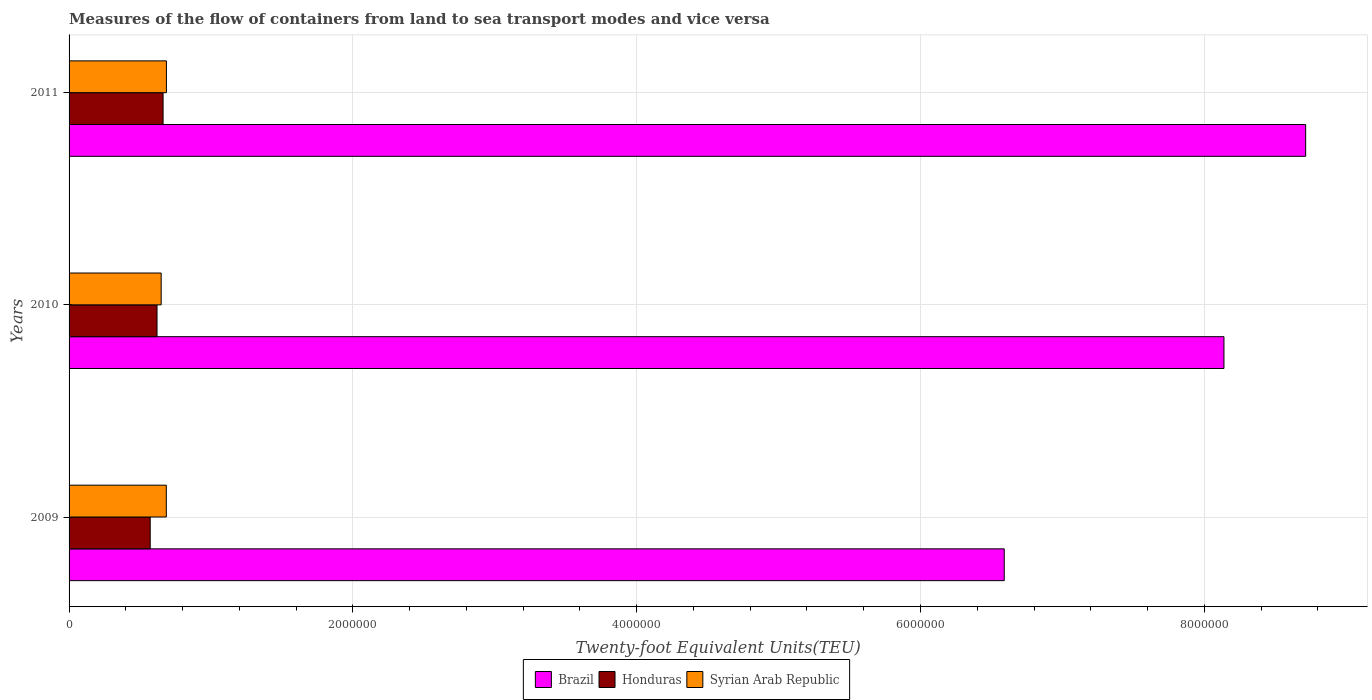Are the number of bars per tick equal to the number of legend labels?
Ensure brevity in your answer.  Yes. How many bars are there on the 1st tick from the top?
Provide a succinct answer. 3. How many bars are there on the 3rd tick from the bottom?
Keep it short and to the point. 3. What is the label of the 2nd group of bars from the top?
Offer a very short reply. 2010. In how many cases, is the number of bars for a given year not equal to the number of legend labels?
Provide a short and direct response. 0. What is the container port traffic in Brazil in 2009?
Provide a succinct answer. 6.59e+06. Across all years, what is the maximum container port traffic in Honduras?
Provide a short and direct response. 6.62e+05. Across all years, what is the minimum container port traffic in Brazil?
Your answer should be compact. 6.59e+06. In which year was the container port traffic in Brazil maximum?
Keep it short and to the point. 2011. In which year was the container port traffic in Syrian Arab Republic minimum?
Give a very brief answer. 2010. What is the total container port traffic in Brazil in the graph?
Your answer should be very brief. 2.34e+07. What is the difference between the container port traffic in Brazil in 2009 and that in 2010?
Give a very brief answer. -1.55e+06. What is the difference between the container port traffic in Honduras in 2010 and the container port traffic in Brazil in 2011?
Your answer should be compact. -8.09e+06. What is the average container port traffic in Brazil per year?
Provide a short and direct response. 7.81e+06. In the year 2010, what is the difference between the container port traffic in Brazil and container port traffic in Syrian Arab Republic?
Provide a short and direct response. 7.49e+06. What is the ratio of the container port traffic in Honduras in 2010 to that in 2011?
Give a very brief answer. 0.94. What is the difference between the highest and the second highest container port traffic in Syrian Arab Republic?
Offer a terse response. 699.29. What is the difference between the highest and the lowest container port traffic in Brazil?
Offer a terse response. 2.12e+06. In how many years, is the container port traffic in Honduras greater than the average container port traffic in Honduras taken over all years?
Your answer should be compact. 2. Is the sum of the container port traffic in Honduras in 2009 and 2011 greater than the maximum container port traffic in Brazil across all years?
Make the answer very short. No. What does the 2nd bar from the top in 2011 represents?
Provide a succinct answer. Honduras. What does the 3rd bar from the bottom in 2009 represents?
Ensure brevity in your answer.  Syrian Arab Republic. Is it the case that in every year, the sum of the container port traffic in Brazil and container port traffic in Syrian Arab Republic is greater than the container port traffic in Honduras?
Your response must be concise. Yes. Does the graph contain grids?
Keep it short and to the point. Yes. Where does the legend appear in the graph?
Provide a succinct answer. Bottom center. What is the title of the graph?
Keep it short and to the point. Measures of the flow of containers from land to sea transport modes and vice versa. What is the label or title of the X-axis?
Your answer should be compact. Twenty-foot Equivalent Units(TEU). What is the label or title of the Y-axis?
Your answer should be compact. Years. What is the Twenty-foot Equivalent Units(TEU) in Brazil in 2009?
Ensure brevity in your answer.  6.59e+06. What is the Twenty-foot Equivalent Units(TEU) in Honduras in 2009?
Your response must be concise. 5.72e+05. What is the Twenty-foot Equivalent Units(TEU) in Syrian Arab Republic in 2009?
Offer a very short reply. 6.85e+05. What is the Twenty-foot Equivalent Units(TEU) in Brazil in 2010?
Give a very brief answer. 8.14e+06. What is the Twenty-foot Equivalent Units(TEU) in Honduras in 2010?
Provide a succinct answer. 6.20e+05. What is the Twenty-foot Equivalent Units(TEU) in Syrian Arab Republic in 2010?
Your response must be concise. 6.49e+05. What is the Twenty-foot Equivalent Units(TEU) of Brazil in 2011?
Make the answer very short. 8.71e+06. What is the Twenty-foot Equivalent Units(TEU) in Honduras in 2011?
Your answer should be compact. 6.62e+05. What is the Twenty-foot Equivalent Units(TEU) in Syrian Arab Republic in 2011?
Offer a terse response. 6.86e+05. Across all years, what is the maximum Twenty-foot Equivalent Units(TEU) of Brazil?
Your answer should be very brief. 8.71e+06. Across all years, what is the maximum Twenty-foot Equivalent Units(TEU) of Honduras?
Your answer should be very brief. 6.62e+05. Across all years, what is the maximum Twenty-foot Equivalent Units(TEU) in Syrian Arab Republic?
Give a very brief answer. 6.86e+05. Across all years, what is the minimum Twenty-foot Equivalent Units(TEU) in Brazil?
Keep it short and to the point. 6.59e+06. Across all years, what is the minimum Twenty-foot Equivalent Units(TEU) of Honduras?
Offer a very short reply. 5.72e+05. Across all years, what is the minimum Twenty-foot Equivalent Units(TEU) in Syrian Arab Republic?
Your answer should be compact. 6.49e+05. What is the total Twenty-foot Equivalent Units(TEU) of Brazil in the graph?
Provide a succinct answer. 2.34e+07. What is the total Twenty-foot Equivalent Units(TEU) in Honduras in the graph?
Provide a succinct answer. 1.85e+06. What is the total Twenty-foot Equivalent Units(TEU) of Syrian Arab Republic in the graph?
Ensure brevity in your answer.  2.02e+06. What is the difference between the Twenty-foot Equivalent Units(TEU) in Brazil in 2009 and that in 2010?
Your answer should be very brief. -1.55e+06. What is the difference between the Twenty-foot Equivalent Units(TEU) in Honduras in 2009 and that in 2010?
Your answer should be very brief. -4.81e+04. What is the difference between the Twenty-foot Equivalent Units(TEU) of Syrian Arab Republic in 2009 and that in 2010?
Your answer should be compact. 3.63e+04. What is the difference between the Twenty-foot Equivalent Units(TEU) of Brazil in 2009 and that in 2011?
Offer a terse response. -2.12e+06. What is the difference between the Twenty-foot Equivalent Units(TEU) of Honduras in 2009 and that in 2011?
Provide a succinct answer. -9.07e+04. What is the difference between the Twenty-foot Equivalent Units(TEU) of Syrian Arab Republic in 2009 and that in 2011?
Your answer should be very brief. -699.28. What is the difference between the Twenty-foot Equivalent Units(TEU) of Brazil in 2010 and that in 2011?
Keep it short and to the point. -5.76e+05. What is the difference between the Twenty-foot Equivalent Units(TEU) in Honduras in 2010 and that in 2011?
Make the answer very short. -4.26e+04. What is the difference between the Twenty-foot Equivalent Units(TEU) in Syrian Arab Republic in 2010 and that in 2011?
Provide a succinct answer. -3.70e+04. What is the difference between the Twenty-foot Equivalent Units(TEU) in Brazil in 2009 and the Twenty-foot Equivalent Units(TEU) in Honduras in 2010?
Keep it short and to the point. 5.97e+06. What is the difference between the Twenty-foot Equivalent Units(TEU) of Brazil in 2009 and the Twenty-foot Equivalent Units(TEU) of Syrian Arab Republic in 2010?
Provide a short and direct response. 5.94e+06. What is the difference between the Twenty-foot Equivalent Units(TEU) of Honduras in 2009 and the Twenty-foot Equivalent Units(TEU) of Syrian Arab Republic in 2010?
Offer a terse response. -7.73e+04. What is the difference between the Twenty-foot Equivalent Units(TEU) in Brazil in 2009 and the Twenty-foot Equivalent Units(TEU) in Honduras in 2011?
Provide a succinct answer. 5.93e+06. What is the difference between the Twenty-foot Equivalent Units(TEU) in Brazil in 2009 and the Twenty-foot Equivalent Units(TEU) in Syrian Arab Republic in 2011?
Provide a short and direct response. 5.90e+06. What is the difference between the Twenty-foot Equivalent Units(TEU) in Honduras in 2009 and the Twenty-foot Equivalent Units(TEU) in Syrian Arab Republic in 2011?
Keep it short and to the point. -1.14e+05. What is the difference between the Twenty-foot Equivalent Units(TEU) in Brazil in 2010 and the Twenty-foot Equivalent Units(TEU) in Honduras in 2011?
Give a very brief answer. 7.48e+06. What is the difference between the Twenty-foot Equivalent Units(TEU) of Brazil in 2010 and the Twenty-foot Equivalent Units(TEU) of Syrian Arab Republic in 2011?
Provide a short and direct response. 7.45e+06. What is the difference between the Twenty-foot Equivalent Units(TEU) of Honduras in 2010 and the Twenty-foot Equivalent Units(TEU) of Syrian Arab Republic in 2011?
Provide a short and direct response. -6.61e+04. What is the average Twenty-foot Equivalent Units(TEU) of Brazil per year?
Provide a succinct answer. 7.81e+06. What is the average Twenty-foot Equivalent Units(TEU) of Honduras per year?
Make the answer very short. 6.18e+05. What is the average Twenty-foot Equivalent Units(TEU) of Syrian Arab Republic per year?
Make the answer very short. 6.73e+05. In the year 2009, what is the difference between the Twenty-foot Equivalent Units(TEU) in Brazil and Twenty-foot Equivalent Units(TEU) in Honduras?
Provide a short and direct response. 6.02e+06. In the year 2009, what is the difference between the Twenty-foot Equivalent Units(TEU) of Brazil and Twenty-foot Equivalent Units(TEU) of Syrian Arab Republic?
Keep it short and to the point. 5.91e+06. In the year 2009, what is the difference between the Twenty-foot Equivalent Units(TEU) of Honduras and Twenty-foot Equivalent Units(TEU) of Syrian Arab Republic?
Your response must be concise. -1.14e+05. In the year 2010, what is the difference between the Twenty-foot Equivalent Units(TEU) in Brazil and Twenty-foot Equivalent Units(TEU) in Honduras?
Provide a succinct answer. 7.52e+06. In the year 2010, what is the difference between the Twenty-foot Equivalent Units(TEU) of Brazil and Twenty-foot Equivalent Units(TEU) of Syrian Arab Republic?
Provide a succinct answer. 7.49e+06. In the year 2010, what is the difference between the Twenty-foot Equivalent Units(TEU) of Honduras and Twenty-foot Equivalent Units(TEU) of Syrian Arab Republic?
Make the answer very short. -2.91e+04. In the year 2011, what is the difference between the Twenty-foot Equivalent Units(TEU) of Brazil and Twenty-foot Equivalent Units(TEU) of Honduras?
Keep it short and to the point. 8.05e+06. In the year 2011, what is the difference between the Twenty-foot Equivalent Units(TEU) in Brazil and Twenty-foot Equivalent Units(TEU) in Syrian Arab Republic?
Give a very brief answer. 8.03e+06. In the year 2011, what is the difference between the Twenty-foot Equivalent Units(TEU) of Honduras and Twenty-foot Equivalent Units(TEU) of Syrian Arab Republic?
Your answer should be very brief. -2.36e+04. What is the ratio of the Twenty-foot Equivalent Units(TEU) in Brazil in 2009 to that in 2010?
Give a very brief answer. 0.81. What is the ratio of the Twenty-foot Equivalent Units(TEU) in Honduras in 2009 to that in 2010?
Provide a short and direct response. 0.92. What is the ratio of the Twenty-foot Equivalent Units(TEU) of Syrian Arab Republic in 2009 to that in 2010?
Your response must be concise. 1.06. What is the ratio of the Twenty-foot Equivalent Units(TEU) in Brazil in 2009 to that in 2011?
Offer a terse response. 0.76. What is the ratio of the Twenty-foot Equivalent Units(TEU) in Honduras in 2009 to that in 2011?
Make the answer very short. 0.86. What is the ratio of the Twenty-foot Equivalent Units(TEU) of Syrian Arab Republic in 2009 to that in 2011?
Ensure brevity in your answer.  1. What is the ratio of the Twenty-foot Equivalent Units(TEU) of Brazil in 2010 to that in 2011?
Your answer should be compact. 0.93. What is the ratio of the Twenty-foot Equivalent Units(TEU) of Honduras in 2010 to that in 2011?
Offer a terse response. 0.94. What is the ratio of the Twenty-foot Equivalent Units(TEU) of Syrian Arab Republic in 2010 to that in 2011?
Offer a terse response. 0.95. What is the difference between the highest and the second highest Twenty-foot Equivalent Units(TEU) of Brazil?
Keep it short and to the point. 5.76e+05. What is the difference between the highest and the second highest Twenty-foot Equivalent Units(TEU) in Honduras?
Provide a short and direct response. 4.26e+04. What is the difference between the highest and the second highest Twenty-foot Equivalent Units(TEU) of Syrian Arab Republic?
Provide a short and direct response. 699.28. What is the difference between the highest and the lowest Twenty-foot Equivalent Units(TEU) of Brazil?
Keep it short and to the point. 2.12e+06. What is the difference between the highest and the lowest Twenty-foot Equivalent Units(TEU) in Honduras?
Make the answer very short. 9.07e+04. What is the difference between the highest and the lowest Twenty-foot Equivalent Units(TEU) of Syrian Arab Republic?
Your answer should be very brief. 3.70e+04. 